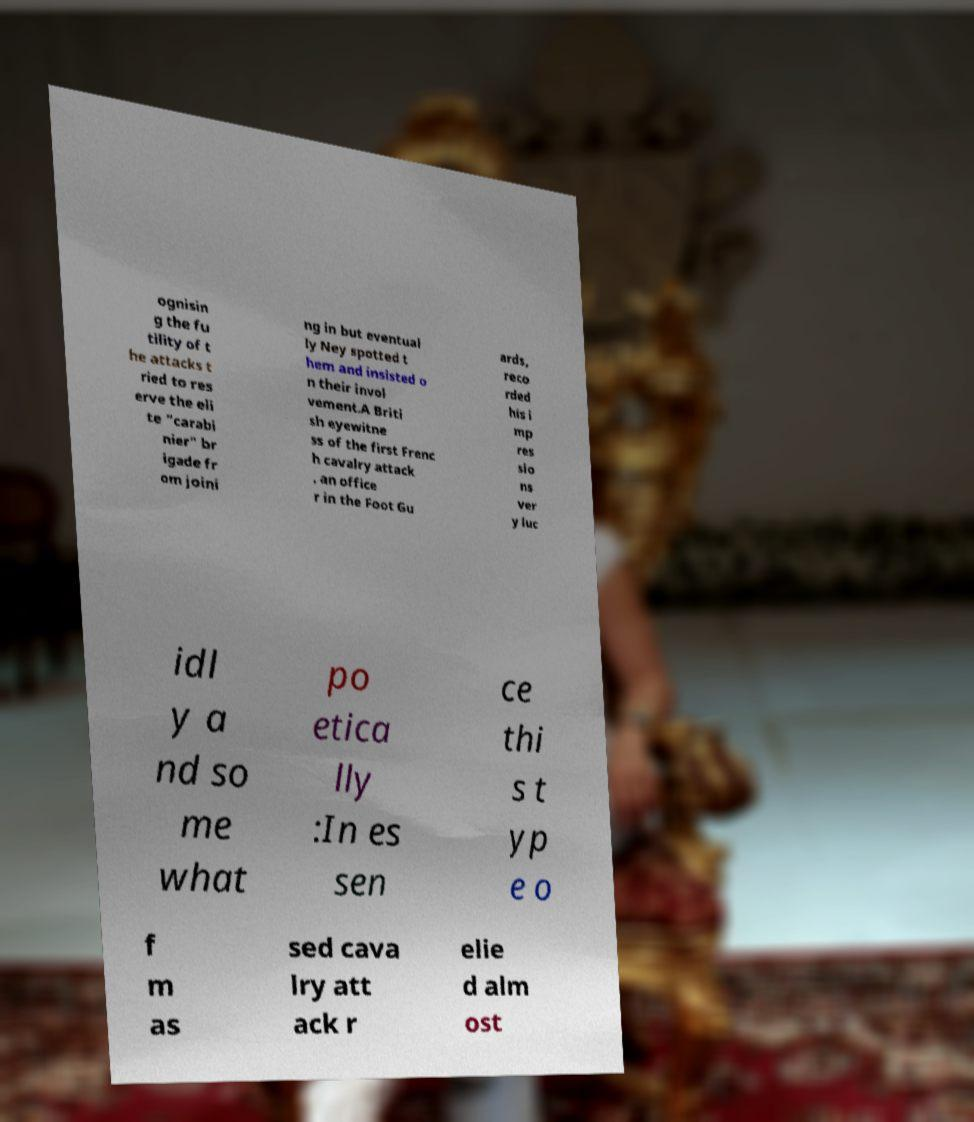Could you assist in decoding the text presented in this image and type it out clearly? ognisin g the fu tility of t he attacks t ried to res erve the eli te "carabi nier" br igade fr om joini ng in but eventual ly Ney spotted t hem and insisted o n their invol vement.A Briti sh eyewitne ss of the first Frenc h cavalry attack , an office r in the Foot Gu ards, reco rded his i mp res sio ns ver y luc idl y a nd so me what po etica lly :In es sen ce thi s t yp e o f m as sed cava lry att ack r elie d alm ost 